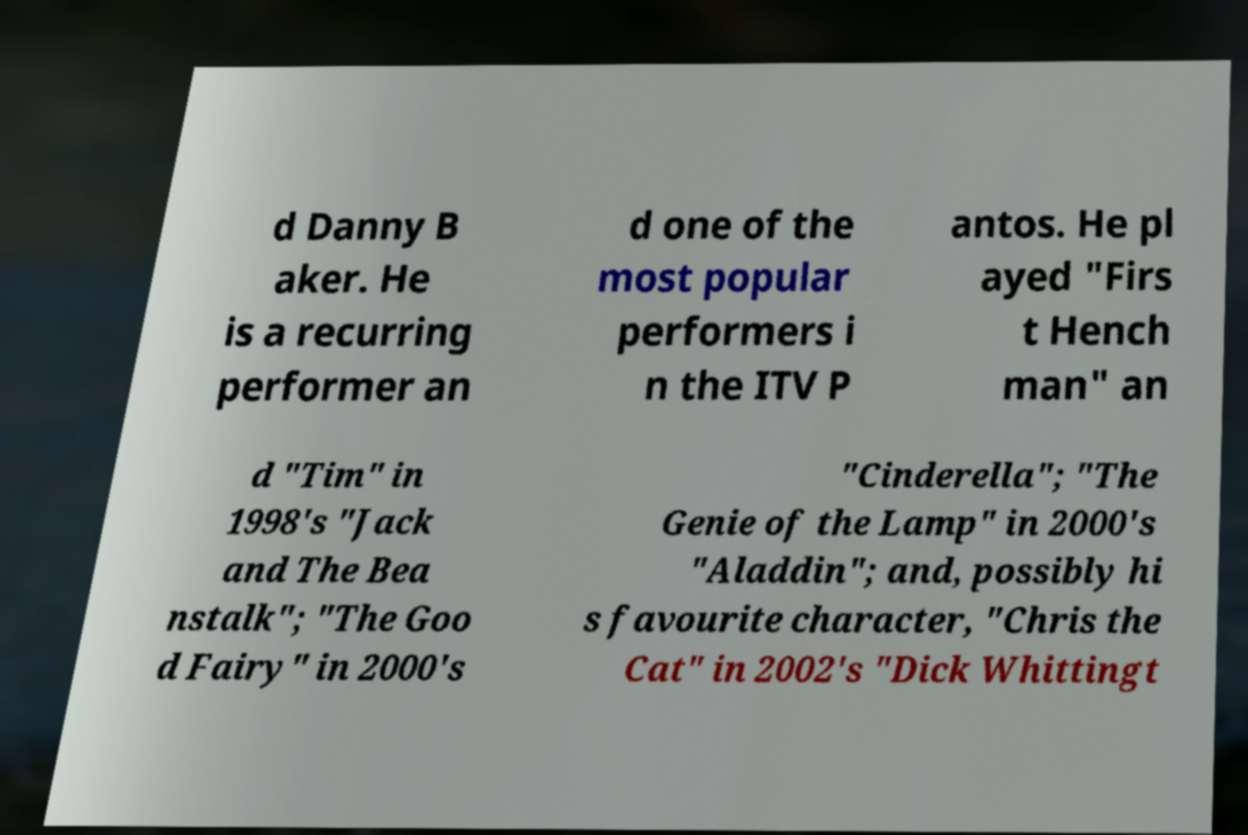Can you accurately transcribe the text from the provided image for me? d Danny B aker. He is a recurring performer an d one of the most popular performers i n the ITV P antos. He pl ayed "Firs t Hench man" an d "Tim" in 1998's "Jack and The Bea nstalk"; "The Goo d Fairy" in 2000's "Cinderella"; "The Genie of the Lamp" in 2000's "Aladdin"; and, possibly hi s favourite character, "Chris the Cat" in 2002's "Dick Whittingt 